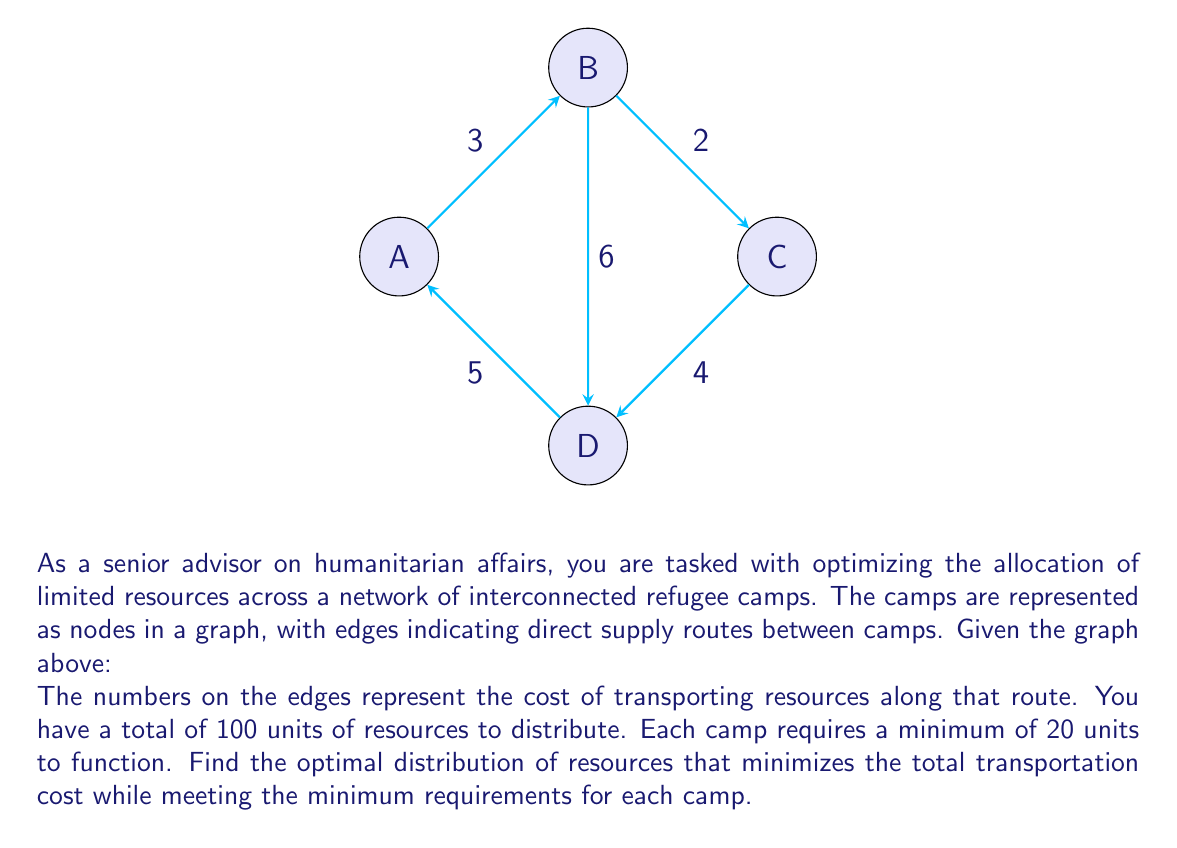Give your solution to this math problem. To solve this problem, we can use the following steps:

1) First, we need to ensure each camp gets the minimum 20 units. This leaves us with 20 units to distribute optimally.

2) To minimize transportation costs, we should distribute the remaining 20 units to the camp that is cheapest to reach from all other camps.

3) To determine this, we can use Dijkstra's algorithm to find the shortest path from each camp to every other camp:

   From A: A→B (3), A→D→C (9), A→D (5)
   From B: B→A (3), B→C (2), B→D (6)
   From C: C→B→A (5), C→B (2), C→D (4)
   From D: D→A (5), D→B (6), D→C (4)

4) Now, we sum up the shortest paths for each camp:
   A: 3 + 9 + 5 = 17
   B: 3 + 2 + 6 = 11
   C: 5 + 2 + 4 = 11
   D: 5 + 6 + 4 = 15

5) Camp B and C tie for the lowest total cost. We can choose either, let's select B.

6) Therefore, the optimal distribution is:
   A: 20 units
   B: 40 units
   C: 20 units
   D: 20 units

7) To calculate the total transportation cost, we need to consider the cost of moving the extra 20 units to B:
   From A to B: 3 * 20 = 60
   From C to B: 2 * 20 = 40
   From D to B: 6 * 20 = 120

   The minimum of these is 40, moving the resources from C to B.

Thus, the optimal distribution minimizes the transportation cost to 40.
Answer: A: 20, B: 40, C: 20, D: 20; Cost: 40 